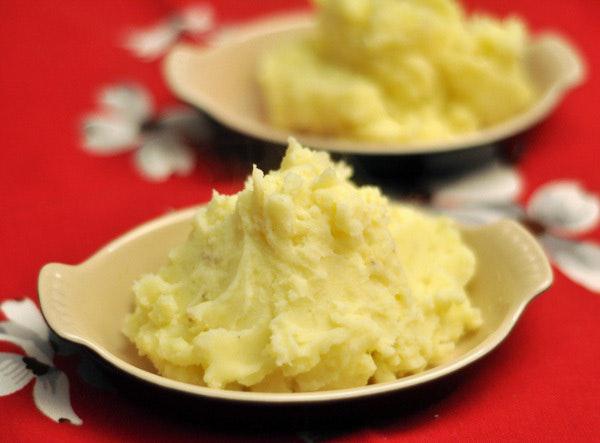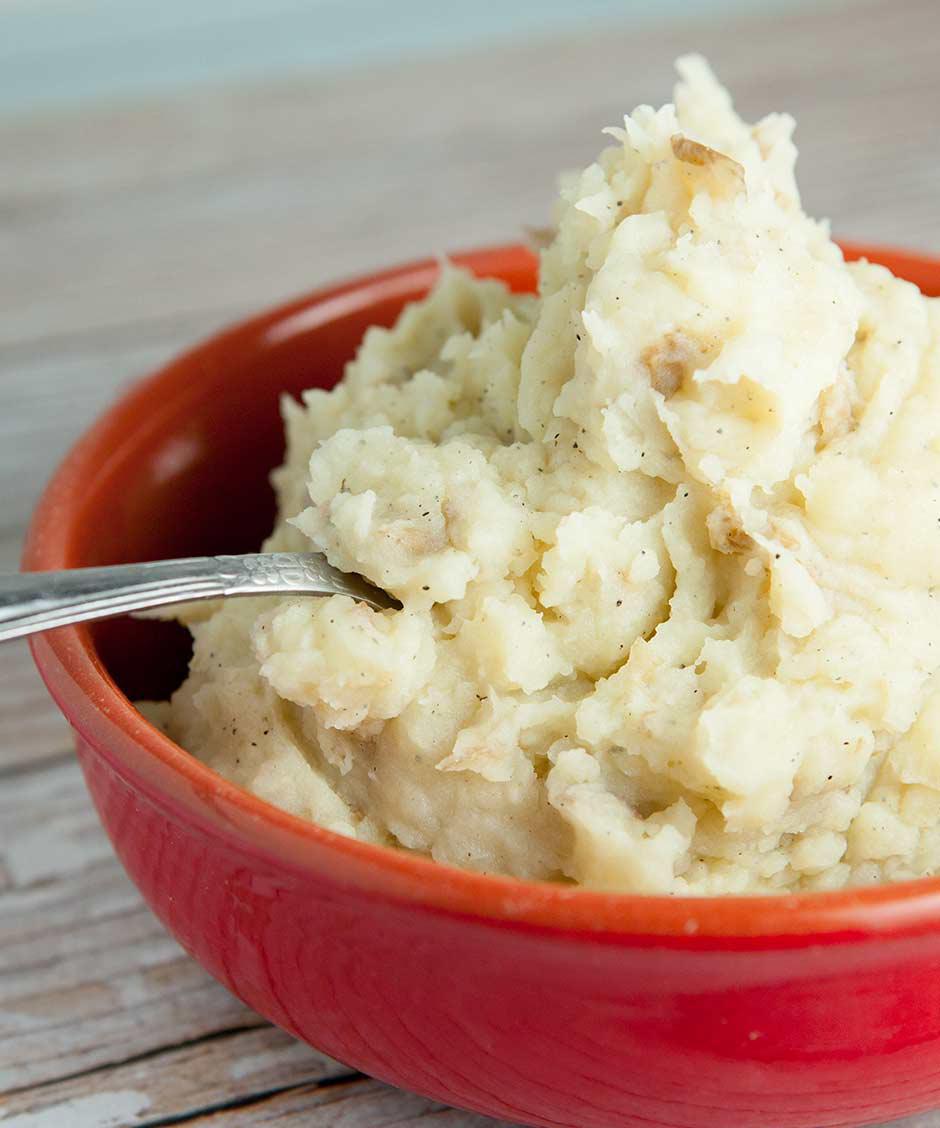The first image is the image on the left, the second image is the image on the right. Given the left and right images, does the statement "The right image shows mashed potatoes served in a bright red bowl, and no image shows a green garnish sprig on top of mashed potatoes." hold true? Answer yes or no. Yes. The first image is the image on the left, the second image is the image on the right. Examine the images to the left and right. Is the description "The right image contains a bowl of mashed potatoes with a spoon handle sticking out of  it." accurate? Answer yes or no. Yes. 